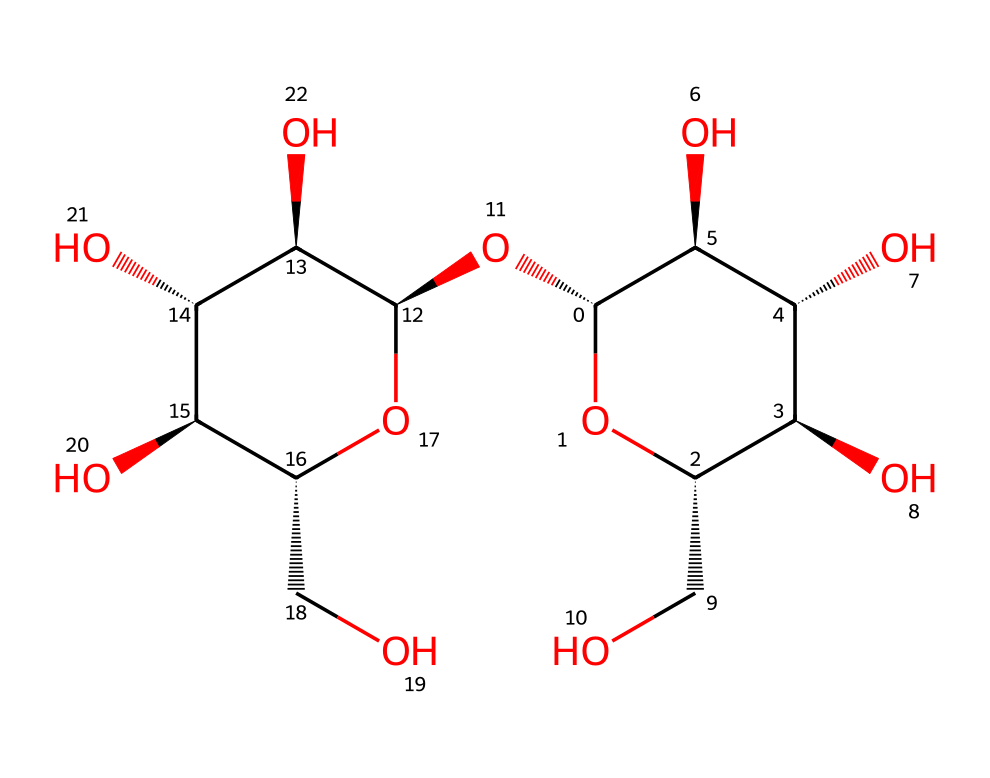What is the main type of polymer found in this rayon fiber? Rayon is a regenerated cellulose fiber, indicated by the repeated glucose-like units in the structure.
Answer: cellulose How many hydroxyl (-OH) groups are present in this chemical structure? By analyzing the structure, there are multiple -OH (hydroxyl) groups attached, specifically 6 visible in the structure.
Answer: 6 What kind of functional groups are mainly present in the structure of this rayon fiber? The dominant functional group in this structure is the hydroxyl group (-OH), which contributes to the fiber's water-absorbing properties.
Answer: hydroxyl group Does this rayon fiber contain any aromatic structures? Upon examining the structure, it is composed entirely of aliphatic chains and does not show any aromatic rings.
Answer: no What property does the presence of multiple hydroxyl groups impart to rayon fibers? The numerous hydroxyl groups increase the fiber's hydrophilicity, enhancing moisture absorption and comfort in clothing.
Answer: hydrophilicity Is this chemical structure stable under high temperature? Rayon fibers may decompose at high temperatures due to the cellulose base, resulting in a change in properties.
Answer: no 